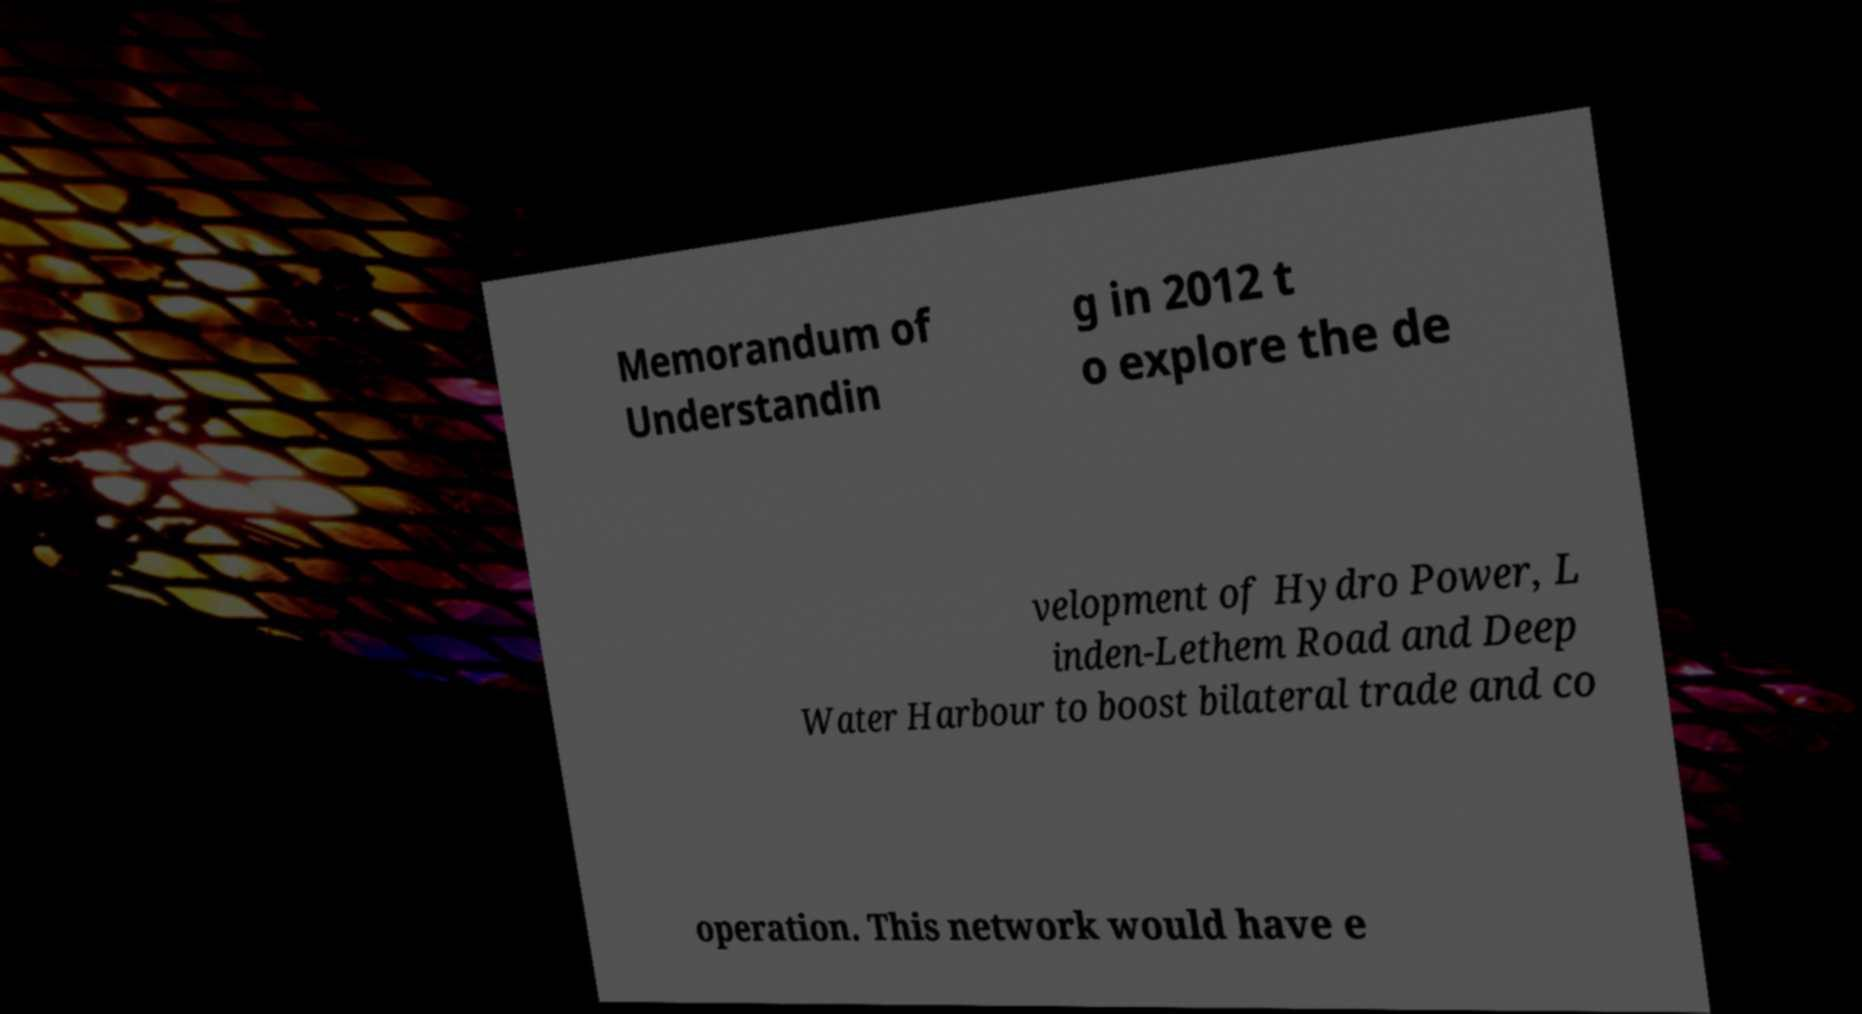Can you read and provide the text displayed in the image?This photo seems to have some interesting text. Can you extract and type it out for me? Memorandum of Understandin g in 2012 t o explore the de velopment of Hydro Power, L inden-Lethem Road and Deep Water Harbour to boost bilateral trade and co operation. This network would have e 